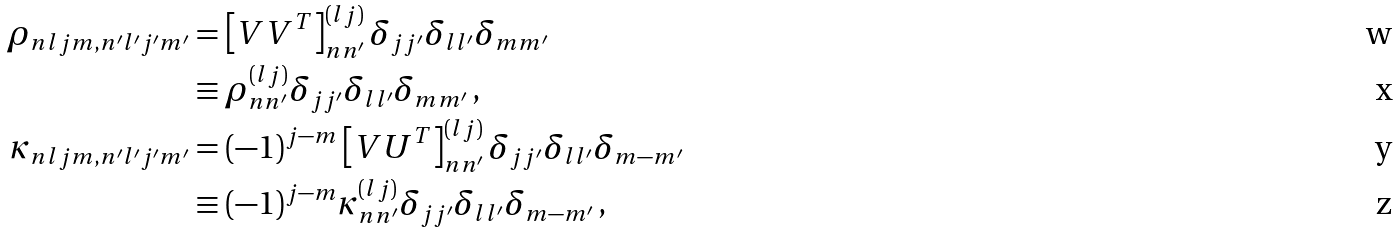Convert formula to latex. <formula><loc_0><loc_0><loc_500><loc_500>\rho _ { n l j m , n ^ { \prime } l ^ { \prime } j ^ { \prime } m ^ { \prime } } & = \left [ V V ^ { T } \right ] ^ { ( l j ) } _ { n n ^ { \prime } } \delta _ { j j ^ { \prime } } \delta _ { l l ^ { \prime } } \delta _ { m m ^ { \prime } } \\ & \equiv \rho ^ { ( l j ) } _ { n n ^ { \prime } } \delta _ { j j ^ { \prime } } \delta _ { l l ^ { \prime } } \delta _ { m m ^ { \prime } } \, , \\ \kappa _ { n l j m , n ^ { \prime } l ^ { \prime } j ^ { \prime } m ^ { \prime } } & = ( - 1 ) ^ { j - m } \left [ V U ^ { T } \right ] ^ { ( l j ) } _ { n n ^ { \prime } } \delta _ { j j ^ { \prime } } \delta _ { l l ^ { \prime } } \delta _ { m - m ^ { \prime } } \\ & \equiv ( - 1 ) ^ { j - m } \kappa ^ { ( l j ) } _ { n n ^ { \prime } } \delta _ { j j ^ { \prime } } \delta _ { l l ^ { \prime } } \delta _ { m - m ^ { \prime } } \, ,</formula> 